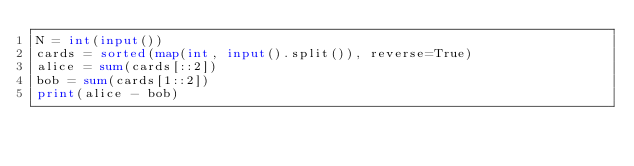Convert code to text. <code><loc_0><loc_0><loc_500><loc_500><_Python_>N = int(input())
cards = sorted(map(int, input().split()), reverse=True)
alice = sum(cards[::2])
bob = sum(cards[1::2])
print(alice - bob)
</code> 